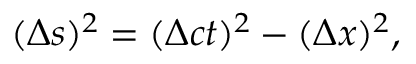<formula> <loc_0><loc_0><loc_500><loc_500>( \Delta s ) ^ { 2 } = ( \Delta c t ) ^ { 2 } - ( \Delta x ) ^ { 2 } ,</formula> 